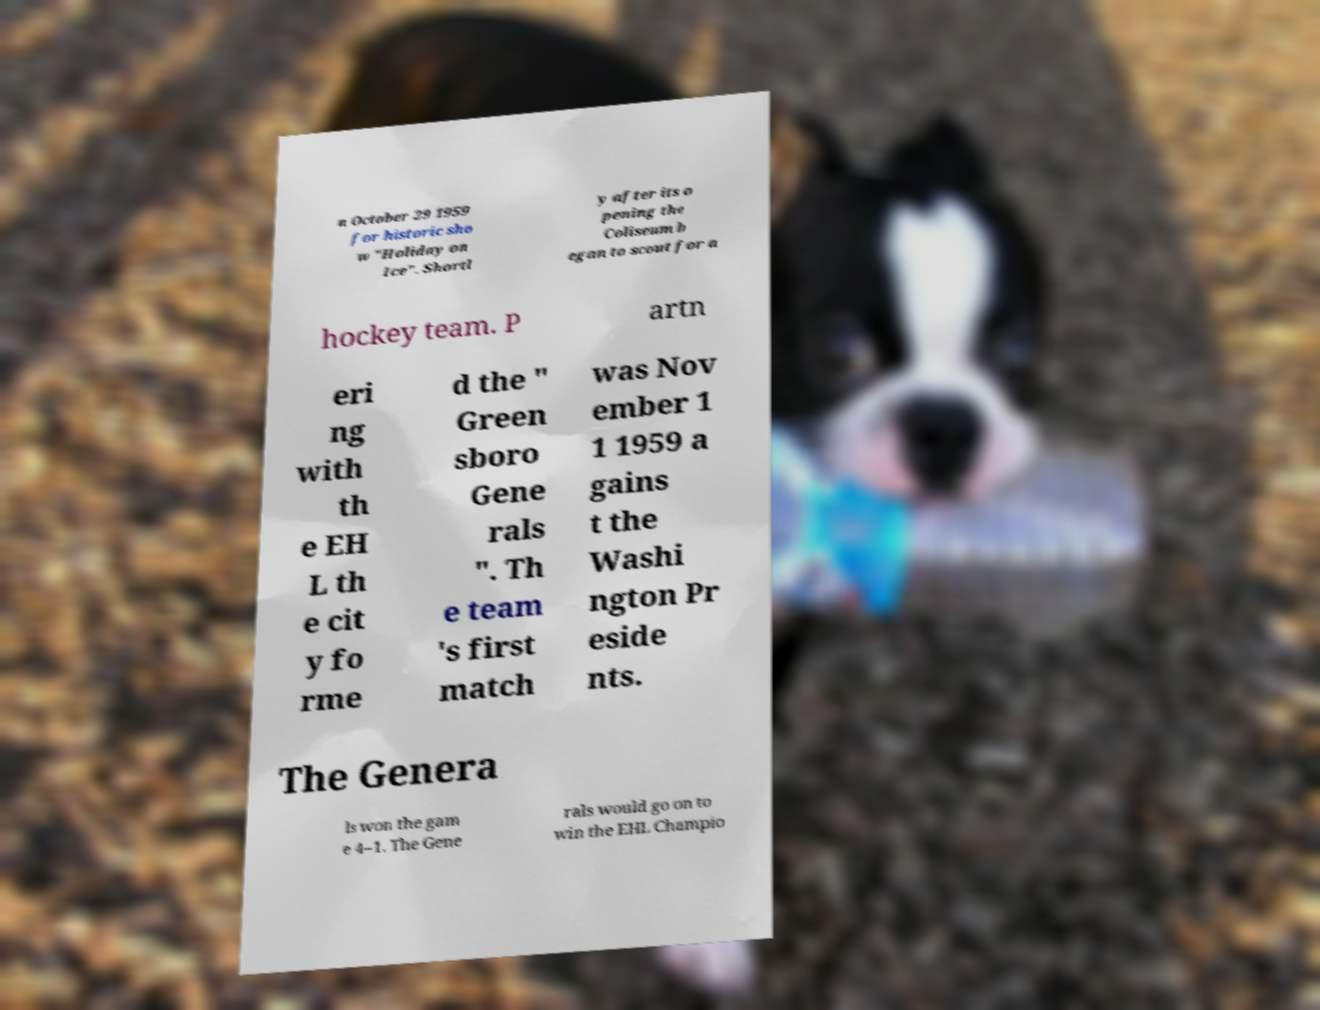Please read and relay the text visible in this image. What does it say? n October 29 1959 for historic sho w "Holiday on Ice". Shortl y after its o pening the Coliseum b egan to scout for a hockey team. P artn eri ng with th e EH L th e cit y fo rme d the " Green sboro Gene rals ". Th e team 's first match was Nov ember 1 1 1959 a gains t the Washi ngton Pr eside nts. The Genera ls won the gam e 4–1. The Gene rals would go on to win the EHL Champio 